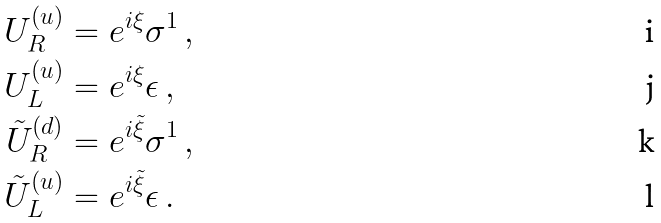<formula> <loc_0><loc_0><loc_500><loc_500>U _ { R } ^ { ( u ) } & = e ^ { i \xi } \sigma ^ { 1 } \, , \\ U _ { L } ^ { ( u ) } & = e ^ { i \xi } \epsilon \, , \\ \tilde { U } _ { R } ^ { ( d ) } & = e ^ { i \tilde { \xi } } \sigma ^ { 1 } \, , \\ \tilde { U } _ { L } ^ { ( u ) } & = e ^ { i \tilde { \xi } } \epsilon \, .</formula> 